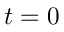<formula> <loc_0><loc_0><loc_500><loc_500>t = 0</formula> 